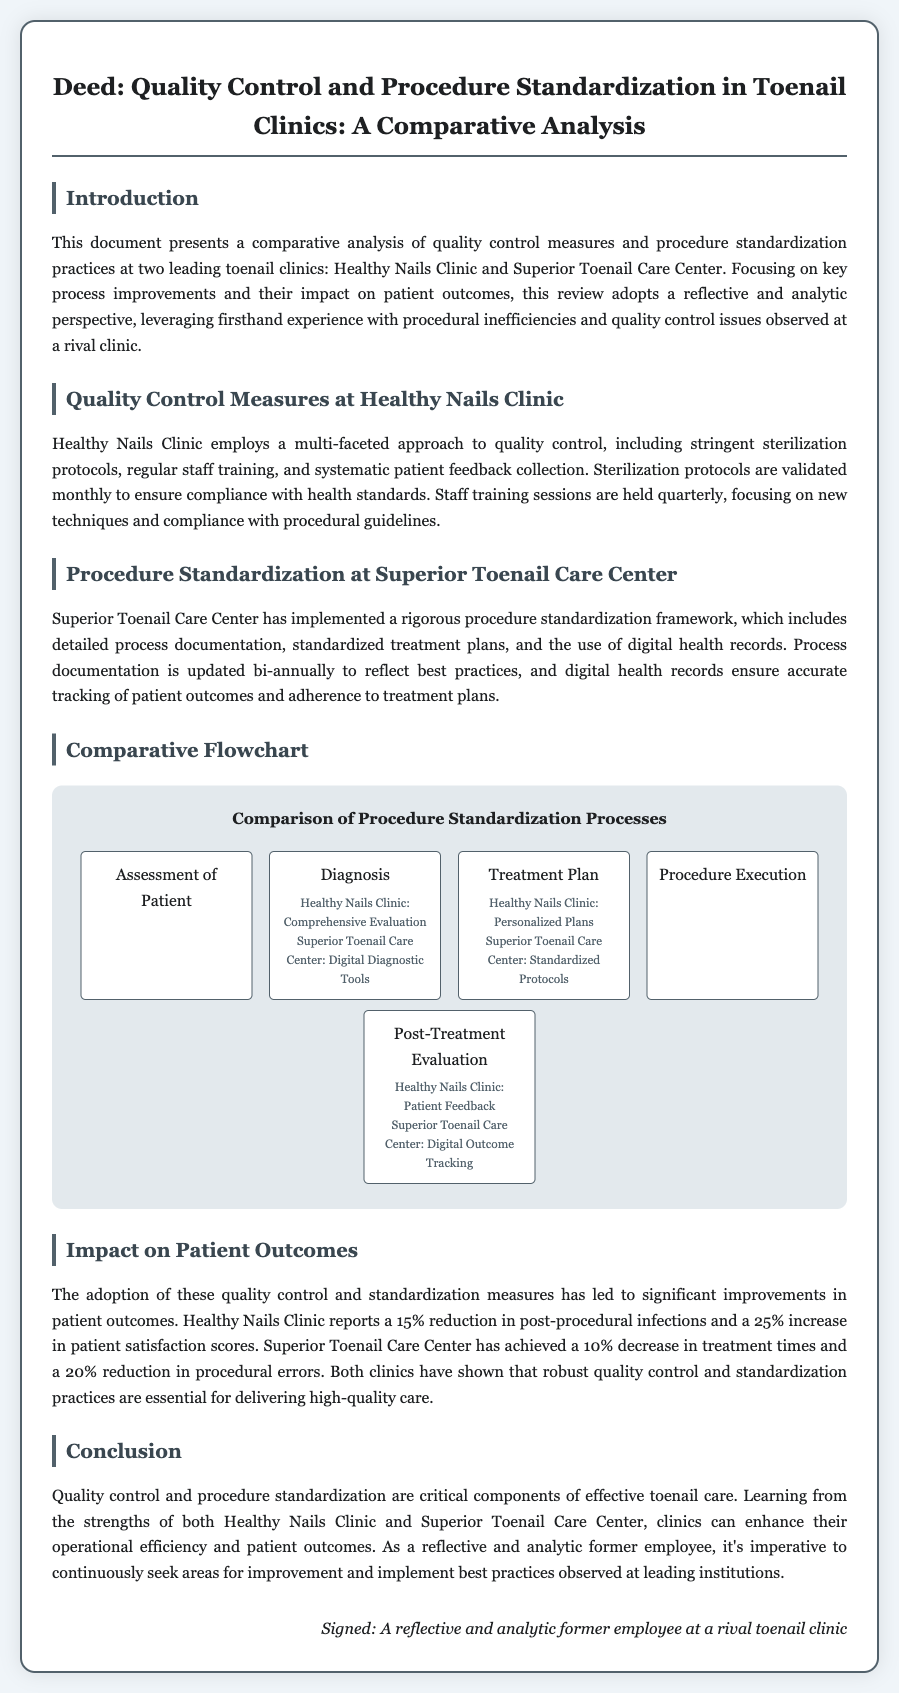What is the title of the document? The title can be found at the top of the rendered document, summarizing its content and purpose.
Answer: Deed: Quality Control and Procedure Standardization in Toenail Clinics: A Comparative Analysis What clinic uses digital diagnostic tools? The document states the methods used by each clinic during the diagnosis phase, indicating which one employs digital tools.
Answer: Superior Toenail Care Center What percentage reduction in post-procedural infections does Healthy Nails Clinic report? The document provides statistics on the impact of the quality control measures, specifically mentioning the reduction in infections.
Answer: 15% How often are staff training sessions held at Healthy Nails Clinic? The document indicates the frequency of staff training sessions, which is part of their quality control measures.
Answer: Quarterly Which clinic has achieved a 20% reduction in procedural errors? The document specifies the patient outcome improvements for each clinic, identifying the one with error reduction.
Answer: Superior Toenail Care Center What is the main focus of the comparative analysis? The introduction reveals the primary emphasis of the analysis, which is key process improvements and their effects.
Answer: Patient outcomes How often is process documentation updated at Superior Toenail Care Center? The document explains the frequency of updates to their process documentation as part of their procedure standardization practice.
Answer: Bi-annually What type of feedback does Healthy Nails Clinic collect? The document describes the methods of quality control at Healthy Nails Clinic, specifically mentioning the type of feedback they use.
Answer: Patient feedback What does the flowchart illustrate? The flowchart section outlines the comparison of certain processes related to the clinics' procedures, depicting the differences.
Answer: Procedure Standardization Processes 